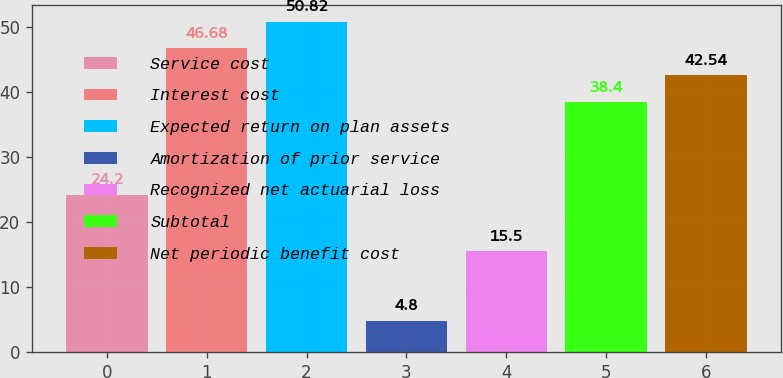Convert chart. <chart><loc_0><loc_0><loc_500><loc_500><bar_chart><fcel>Service cost<fcel>Interest cost<fcel>Expected return on plan assets<fcel>Amortization of prior service<fcel>Recognized net actuarial loss<fcel>Subtotal<fcel>Net periodic benefit cost<nl><fcel>24.2<fcel>46.68<fcel>50.82<fcel>4.8<fcel>15.5<fcel>38.4<fcel>42.54<nl></chart> 